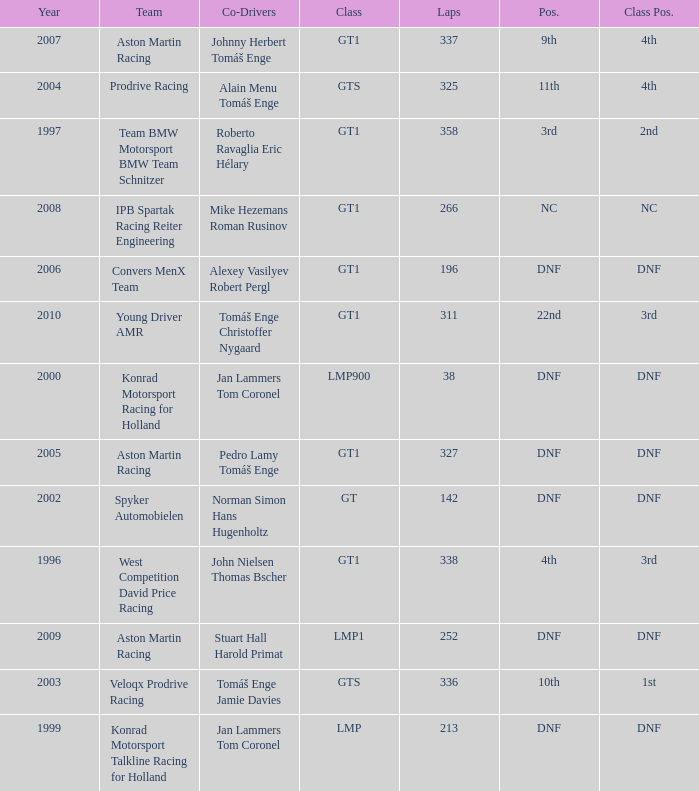Which team finished 3rd in class with 337 laps before 2008? West Competition David Price Racing. 